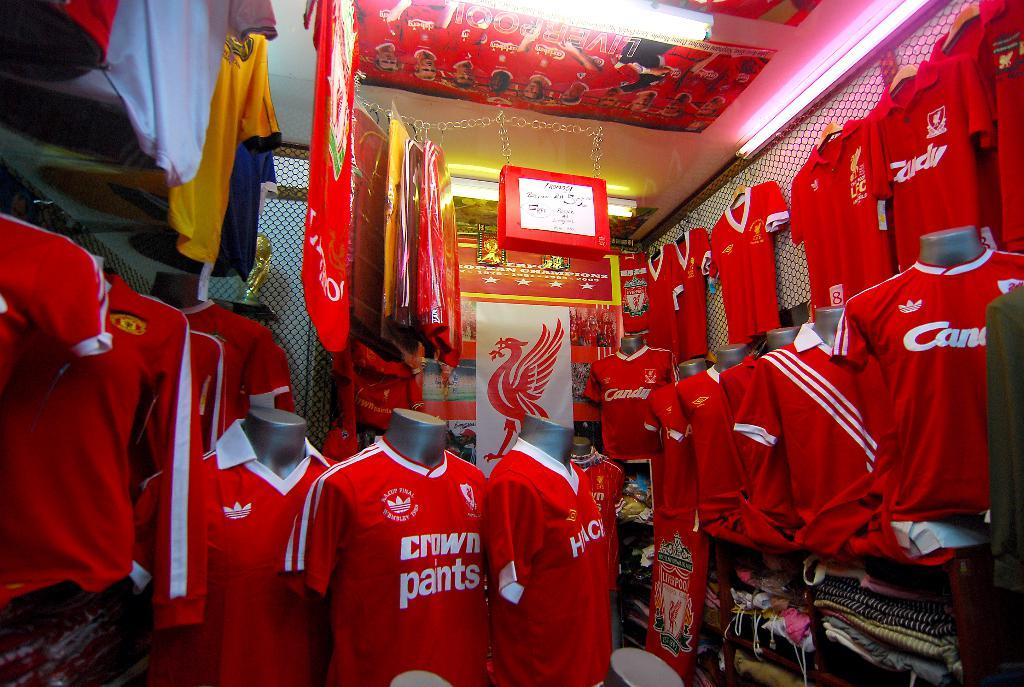<image>
Present a compact description of the photo's key features. A shirt labeled "Crown Pants" sits between two other shirts in the front of the store. 